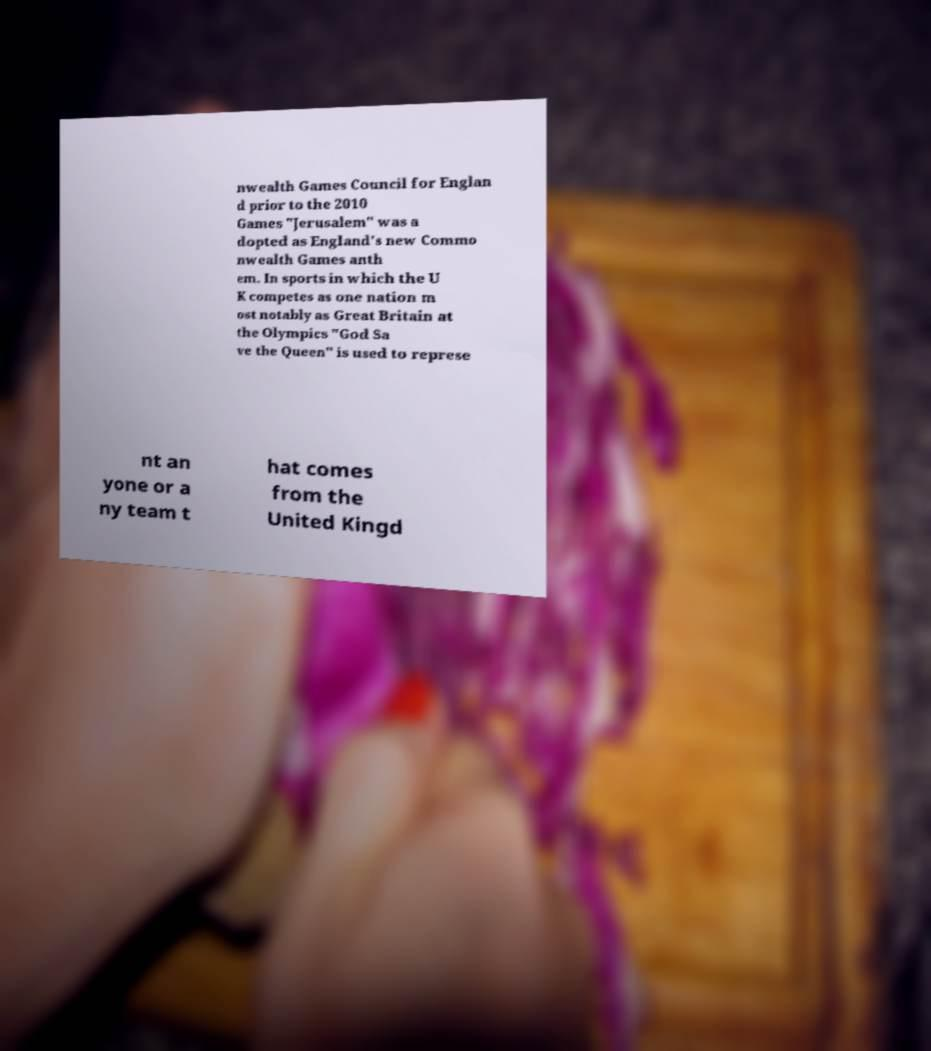What messages or text are displayed in this image? I need them in a readable, typed format. nwealth Games Council for Englan d prior to the 2010 Games "Jerusalem" was a dopted as England's new Commo nwealth Games anth em. In sports in which the U K competes as one nation m ost notably as Great Britain at the Olympics "God Sa ve the Queen" is used to represe nt an yone or a ny team t hat comes from the United Kingd 